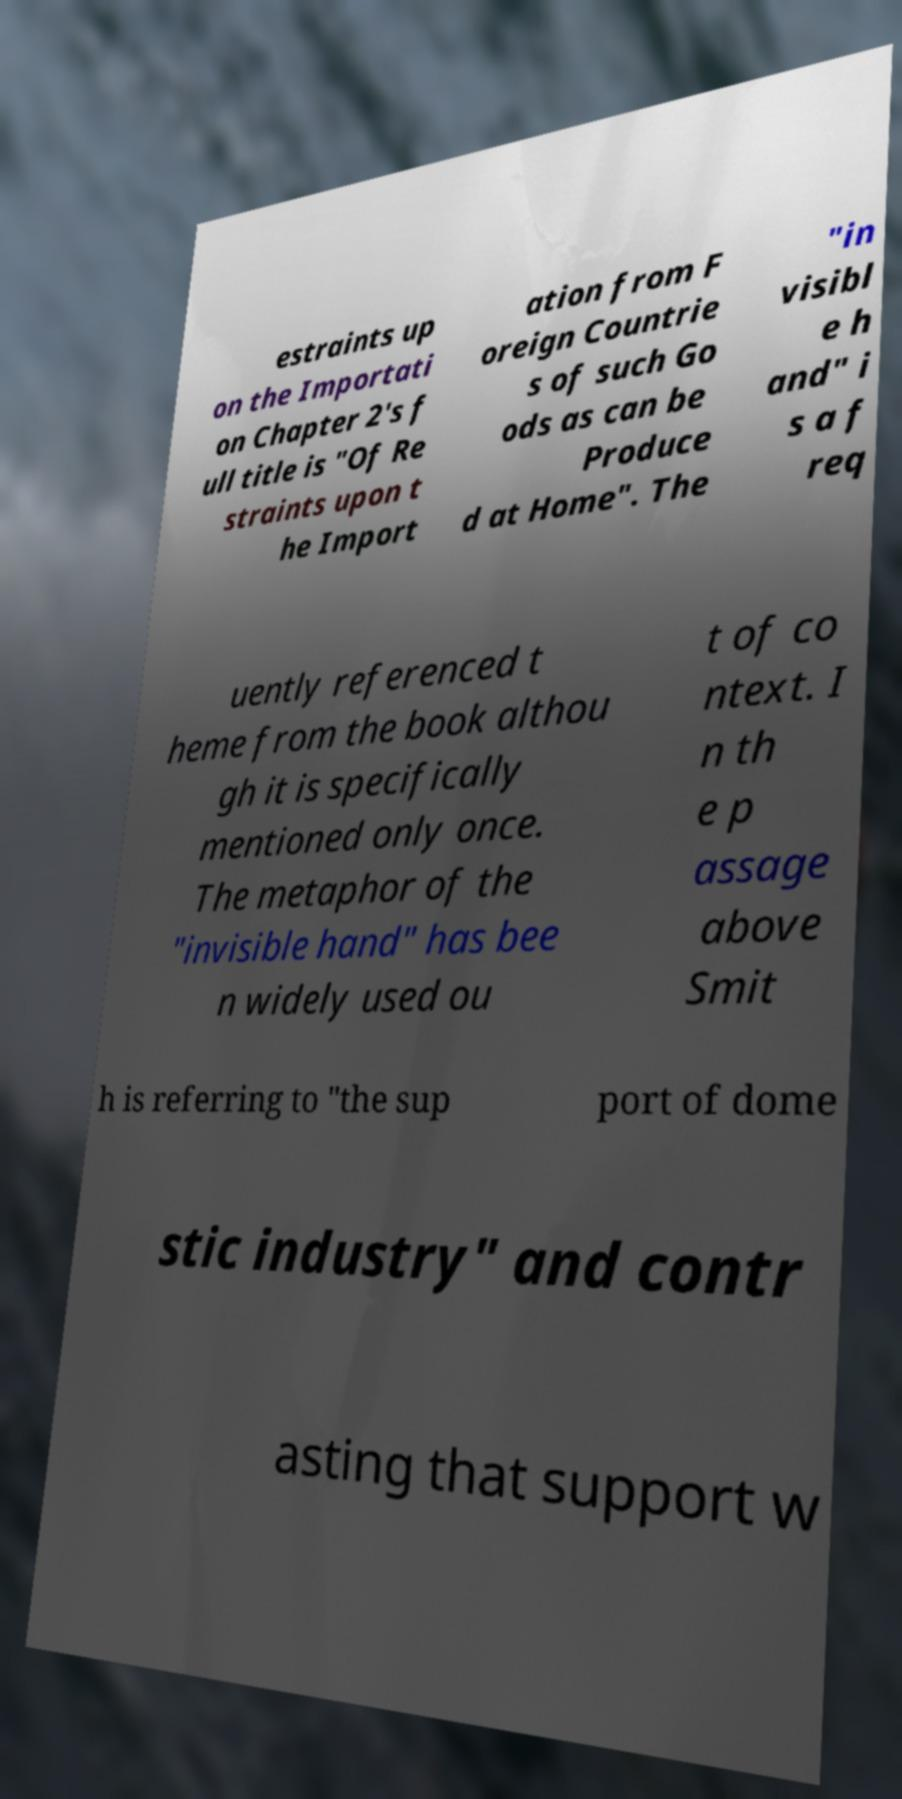For documentation purposes, I need the text within this image transcribed. Could you provide that? estraints up on the Importati on Chapter 2's f ull title is "Of Re straints upon t he Import ation from F oreign Countrie s of such Go ods as can be Produce d at Home". The "in visibl e h and" i s a f req uently referenced t heme from the book althou gh it is specifically mentioned only once. The metaphor of the "invisible hand" has bee n widely used ou t of co ntext. I n th e p assage above Smit h is referring to "the sup port of dome stic industry" and contr asting that support w 